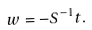Convert formula to latex. <formula><loc_0><loc_0><loc_500><loc_500>w = - S ^ { - 1 } t .</formula> 